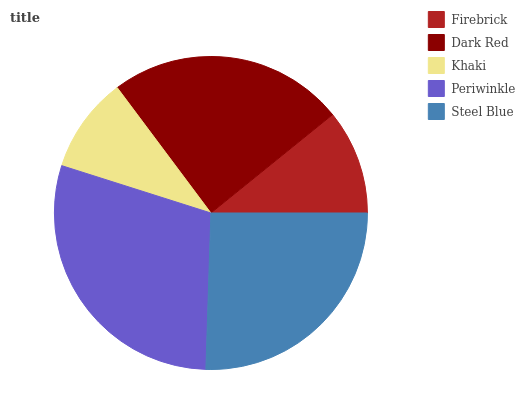Is Khaki the minimum?
Answer yes or no. Yes. Is Periwinkle the maximum?
Answer yes or no. Yes. Is Dark Red the minimum?
Answer yes or no. No. Is Dark Red the maximum?
Answer yes or no. No. Is Dark Red greater than Firebrick?
Answer yes or no. Yes. Is Firebrick less than Dark Red?
Answer yes or no. Yes. Is Firebrick greater than Dark Red?
Answer yes or no. No. Is Dark Red less than Firebrick?
Answer yes or no. No. Is Dark Red the high median?
Answer yes or no. Yes. Is Dark Red the low median?
Answer yes or no. Yes. Is Periwinkle the high median?
Answer yes or no. No. Is Firebrick the low median?
Answer yes or no. No. 